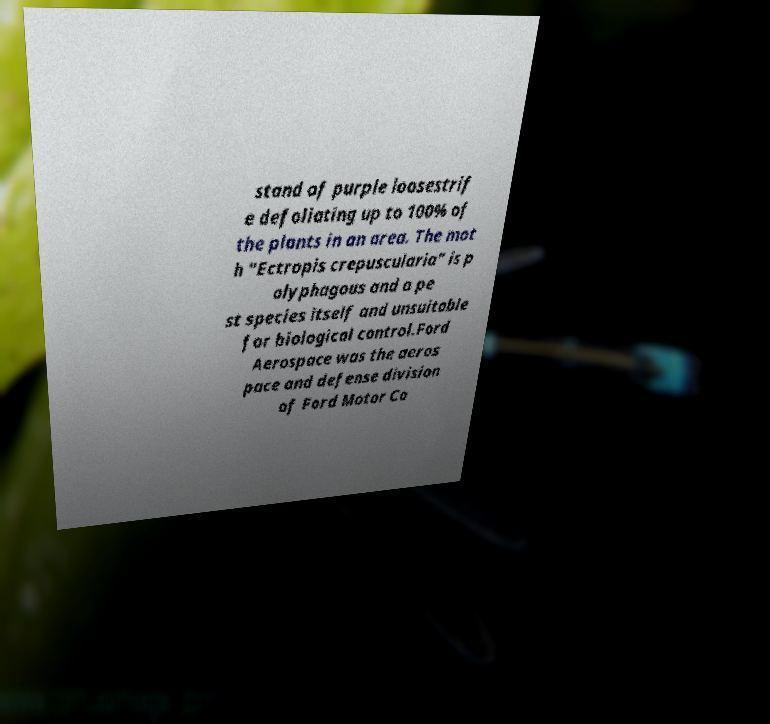I need the written content from this picture converted into text. Can you do that? stand of purple loosestrif e defoliating up to 100% of the plants in an area. The mot h "Ectropis crepuscularia" is p olyphagous and a pe st species itself and unsuitable for biological control.Ford Aerospace was the aeros pace and defense division of Ford Motor Co 